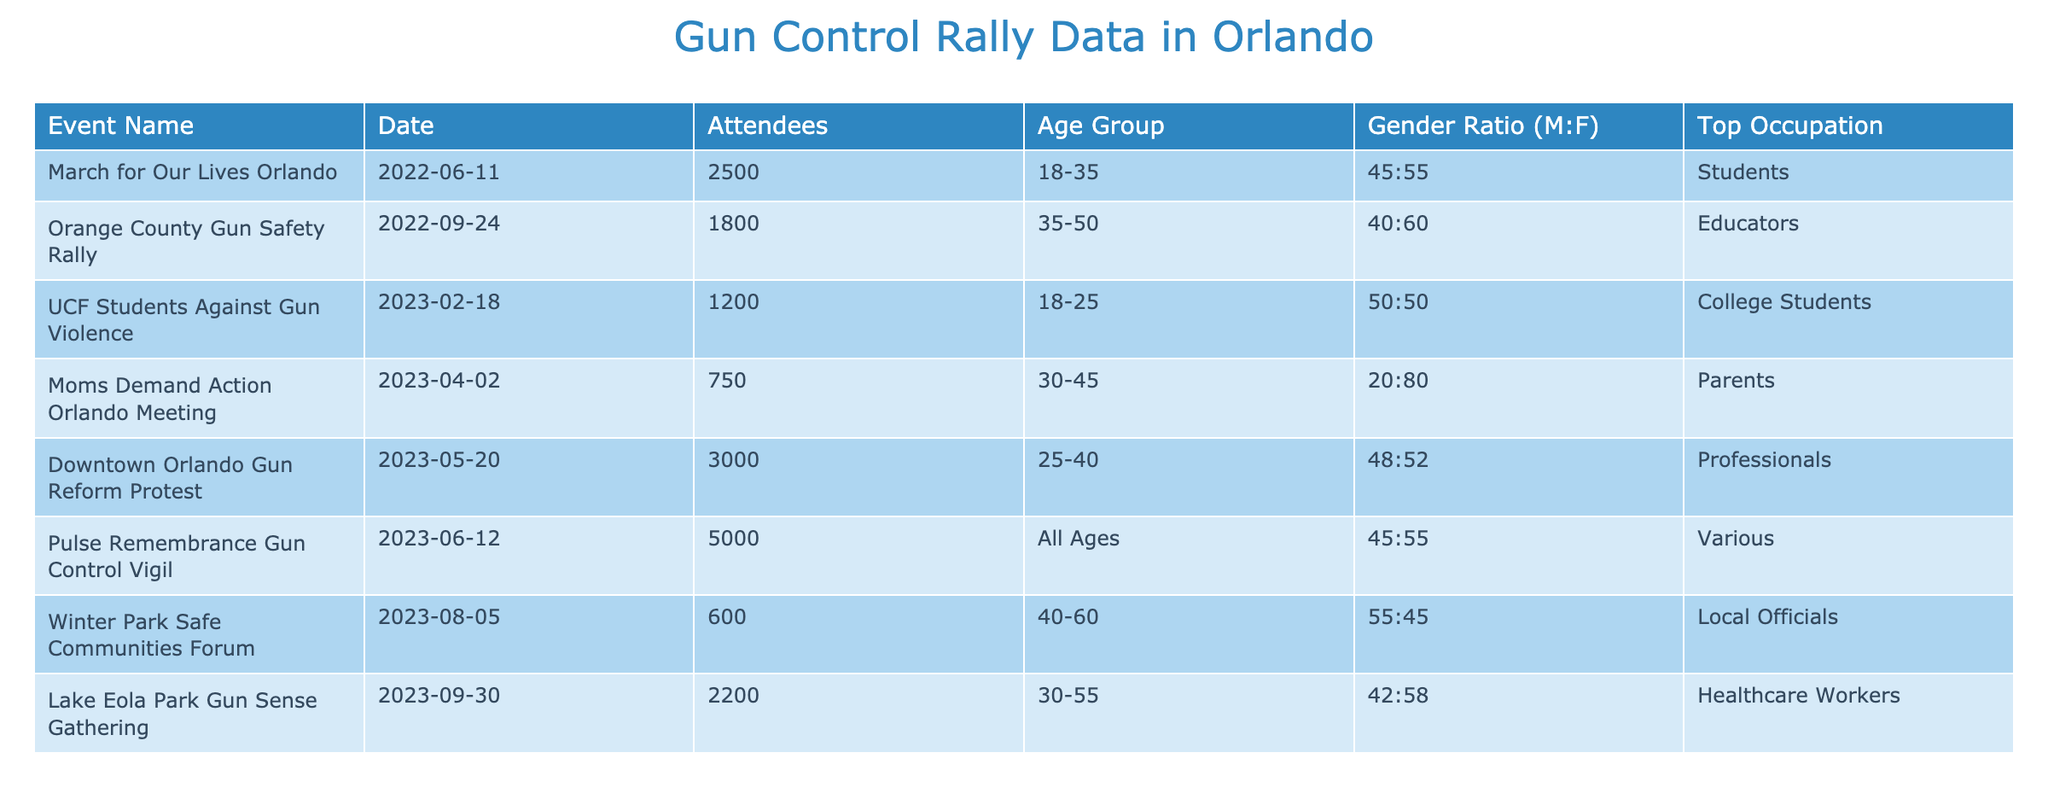What is the total number of attendees at all rallies listed in the table? To find the total number of attendees, we need to sum the "Attendees" column across all events. The numbers are 2500 (March for Our Lives) + 1800 (Orange County Gun Safety Rally) + 1200 (UCF Students Against Gun Violence) + 750 (Moms Demand Action) + 3000 (Downtown Orlando Gun Reform) + 5000 (Pulse Vigil) + 600 (Winter Park Forum) + 2200 (Lake Eola Gathering) =  2500 + 1800 + 1200 + 750 + 3000 + 5000 + 600 + 2200 =  18850
Answer: 18850 What age group had the highest attendance? Looking at the table, the highest number of attendees is 5000 for the Pulse Remembrance Gun Control Vigil, which has "All Ages" as the age group. Therefore, "All Ages" is the age group with the highest attendance.
Answer: All Ages Is the gender ratio in the Downtown Orlando Gun Reform Protest balanced? The gender ratio for the Downtown Orlando Gun Reform Protest is 48:52 (Male:Female), which indicates a slight imbalance leaning towards females. Since a balanced ratio would require both genders to have equal representation (e.g., 50:50), the answer is no.
Answer: No How does the average attendee age group range compare between the rallies focusing on younger participants (18-35) and older participants (40-60)? For the younger group (18-35), the age groups in consideration are 18-35 (from March for Our Lives and UCF Students) and 25-40 (from Downtown Orlando). Their respective totals are 2500 + 1200 + 3000 = 6700 attendees. The average age group would be (18+35)/2 = 26.5. For the older group (40-60), we consider Winter Park and Lake Eola gatherings. Their totals are 600 + 2200 = 2800 attendees. The average age is (40+60)/2 = 50. Comparing, the younger group has an average of 26.5 with 6700 attendees, while the older group has an average of 50 with 2800 attendees.
Answer: Younger: 26.5; Older: 50 Which event had the most professionals attending? Looking closely at the "Top Occupation" column, the only event that lists "Professionals" as their top occupation is the Downtown Orlando Gun Reform Protest, which had 3000 attendees. No other event listed "Professionals," confirming it had the most professionals.
Answer: Downtown Orlando Gun Reform Protest Did the Moms Demand Action Orlando Meeting have more attendees compared to the Winter Park Safe Communities Forum? The Moms Demand Action Orlando Meeting had 750 attendees while the Winter Park Safe Communities Forum had 600 attendees. Since 750 is greater than 600, this means that Moms Demand Action had more attendees than the Winter Park Forum.
Answer: Yes 